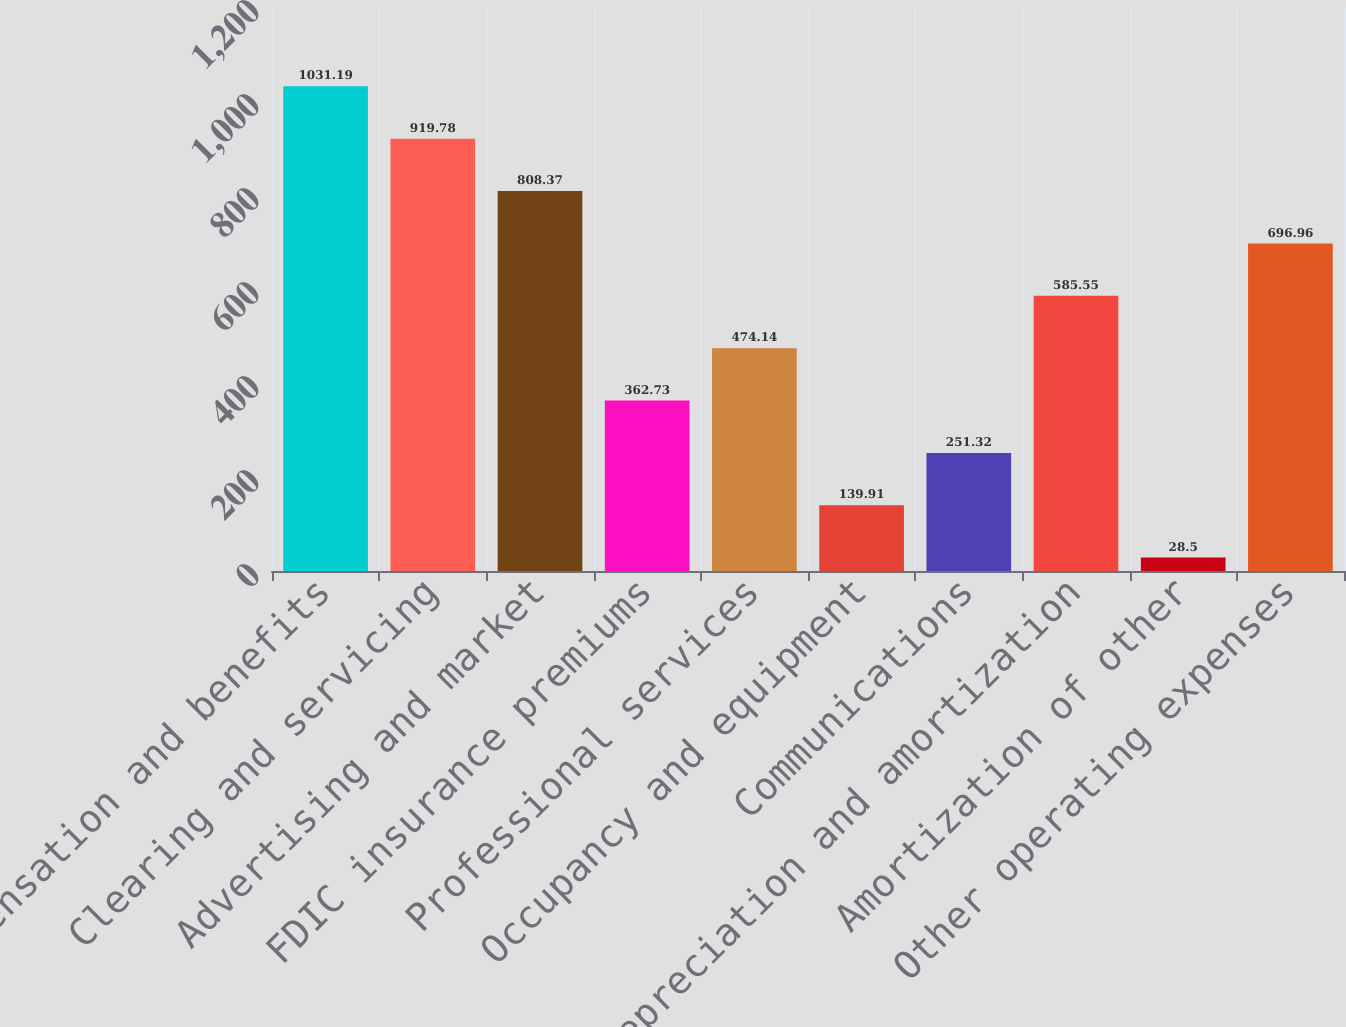Convert chart to OTSL. <chart><loc_0><loc_0><loc_500><loc_500><bar_chart><fcel>Compensation and benefits<fcel>Clearing and servicing<fcel>Advertising and market<fcel>FDIC insurance premiums<fcel>Professional services<fcel>Occupancy and equipment<fcel>Communications<fcel>Depreciation and amortization<fcel>Amortization of other<fcel>Other operating expenses<nl><fcel>1031.19<fcel>919.78<fcel>808.37<fcel>362.73<fcel>474.14<fcel>139.91<fcel>251.32<fcel>585.55<fcel>28.5<fcel>696.96<nl></chart> 